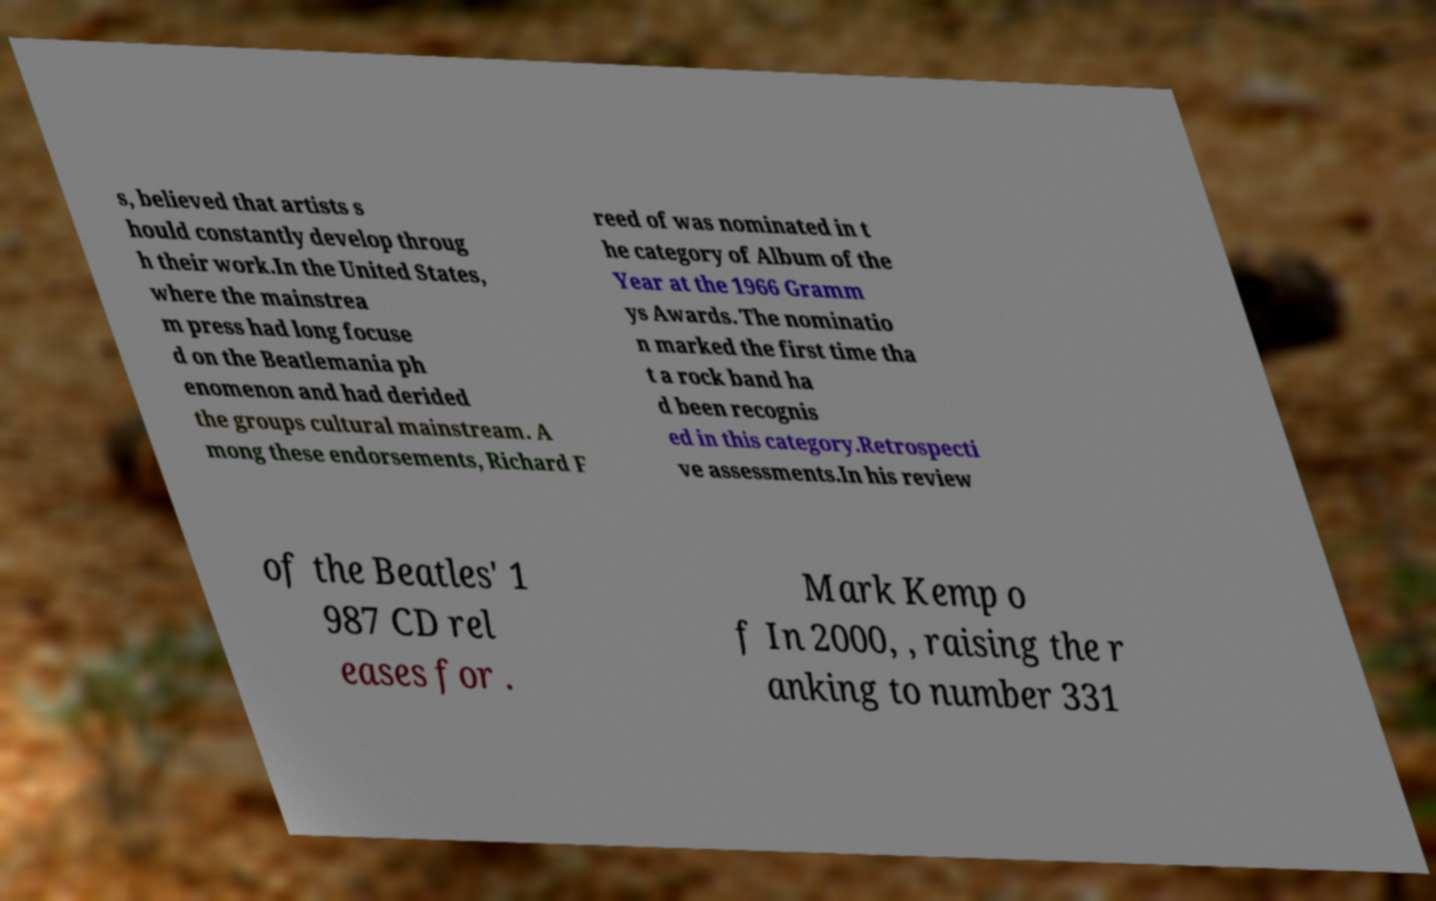For documentation purposes, I need the text within this image transcribed. Could you provide that? s, believed that artists s hould constantly develop throug h their work.In the United States, where the mainstrea m press had long focuse d on the Beatlemania ph enomenon and had derided the groups cultural mainstream. A mong these endorsements, Richard F reed of was nominated in t he category of Album of the Year at the 1966 Gramm ys Awards. The nominatio n marked the first time tha t a rock band ha d been recognis ed in this category.Retrospecti ve assessments.In his review of the Beatles' 1 987 CD rel eases for . Mark Kemp o f In 2000, , raising the r anking to number 331 